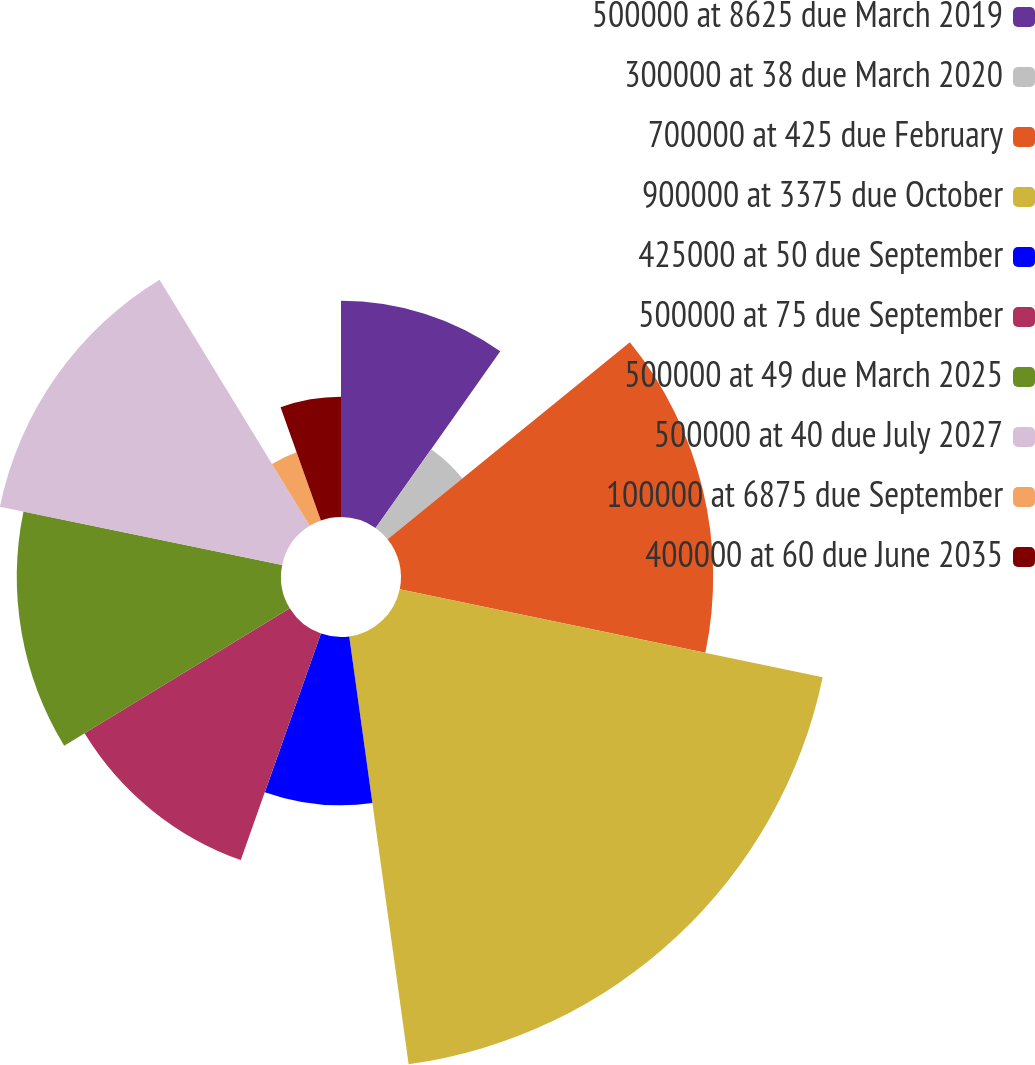Convert chart to OTSL. <chart><loc_0><loc_0><loc_500><loc_500><pie_chart><fcel>500000 at 8625 due March 2019<fcel>300000 at 38 due March 2020<fcel>700000 at 425 due February<fcel>900000 at 3375 due October<fcel>425000 at 50 due September<fcel>500000 at 75 due September<fcel>500000 at 49 due March 2025<fcel>500000 at 40 due July 2027<fcel>100000 at 6875 due September<fcel>400000 at 60 due June 2035<nl><fcel>9.78%<fcel>4.36%<fcel>14.12%<fcel>19.54%<fcel>7.61%<fcel>10.87%<fcel>11.95%<fcel>13.04%<fcel>3.28%<fcel>5.44%<nl></chart> 